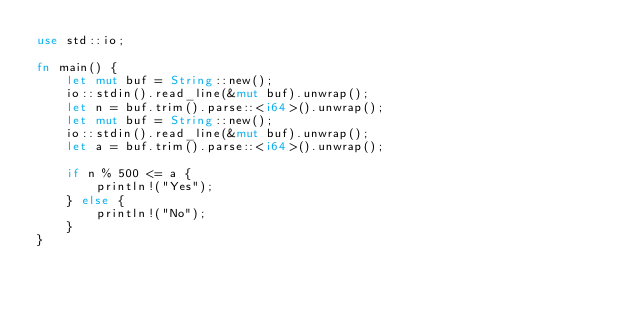<code> <loc_0><loc_0><loc_500><loc_500><_Rust_>use std::io;

fn main() {
    let mut buf = String::new();
    io::stdin().read_line(&mut buf).unwrap();
    let n = buf.trim().parse::<i64>().unwrap();
    let mut buf = String::new();
    io::stdin().read_line(&mut buf).unwrap();
    let a = buf.trim().parse::<i64>().unwrap();

    if n % 500 <= a {
        println!("Yes");
    } else {
        println!("No");
    }
}
</code> 